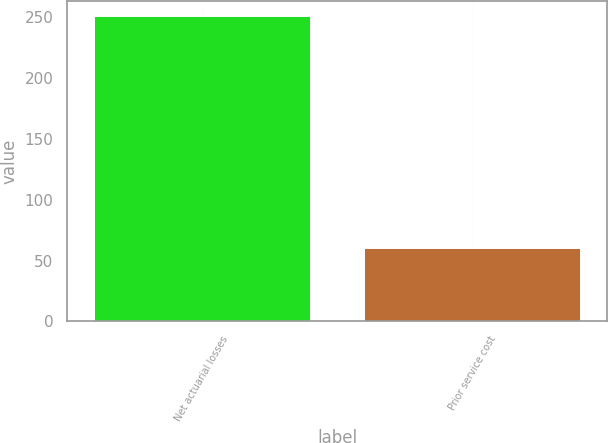Convert chart to OTSL. <chart><loc_0><loc_0><loc_500><loc_500><bar_chart><fcel>Net actuarial losses<fcel>Prior service cost<nl><fcel>251<fcel>60<nl></chart> 